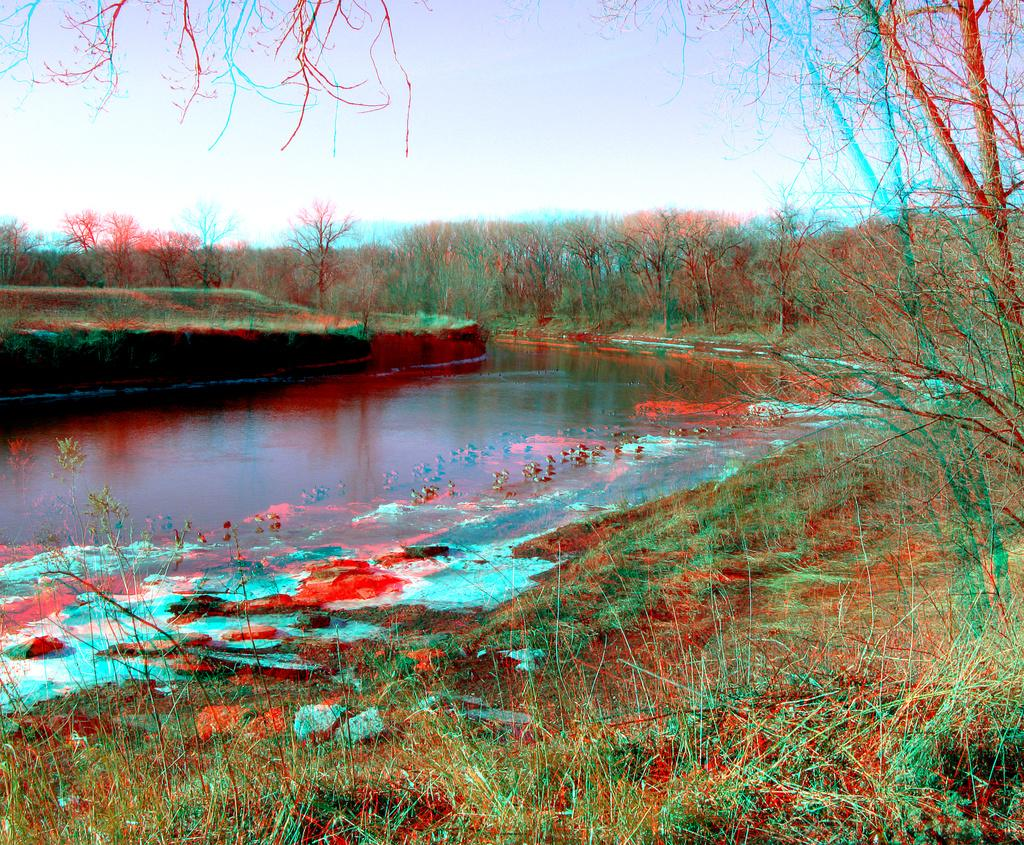What type of body of water is present in the image? There is a lake in the image. What can be seen in the distance behind the lake? There are trees in the background of the image. How many sheep can be seen in the image? There are no sheep present in the image. Was the lake formed due to an earthquake in the image? There is no information about the formation of the lake or any earthquake in the image. 